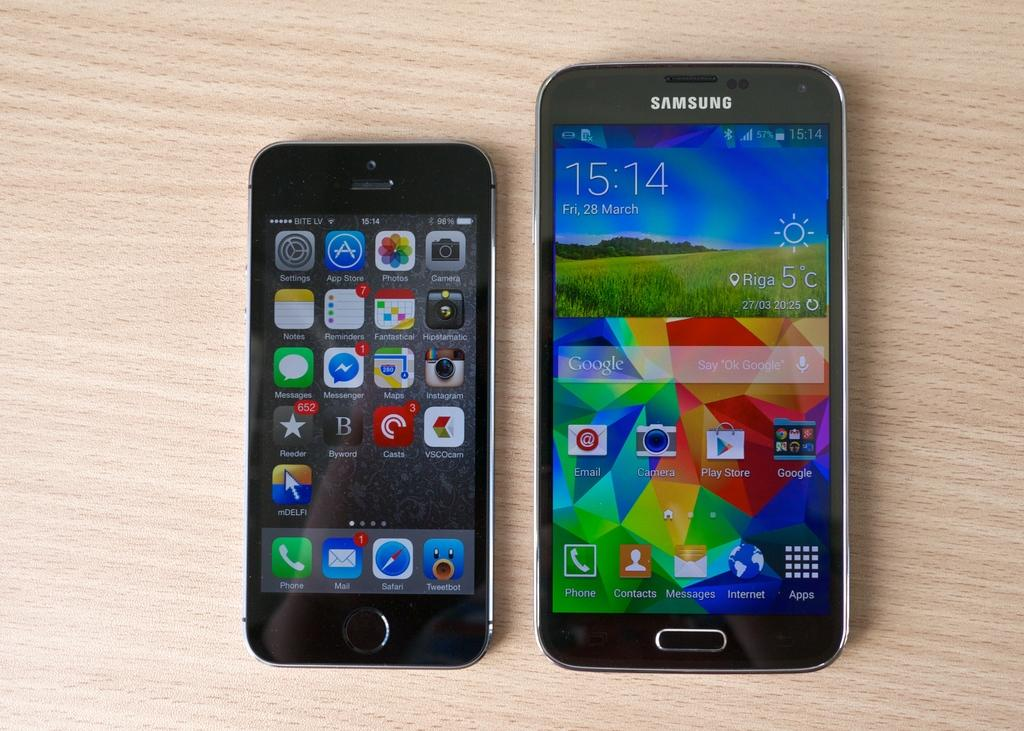What type of electronic devices can be seen in the image? Mobile phones can be seen in the image. What type of knowledge can be gained from the hot drawer in the image? There is no hot drawer present in the image, and therefore no knowledge can be gained from it. 